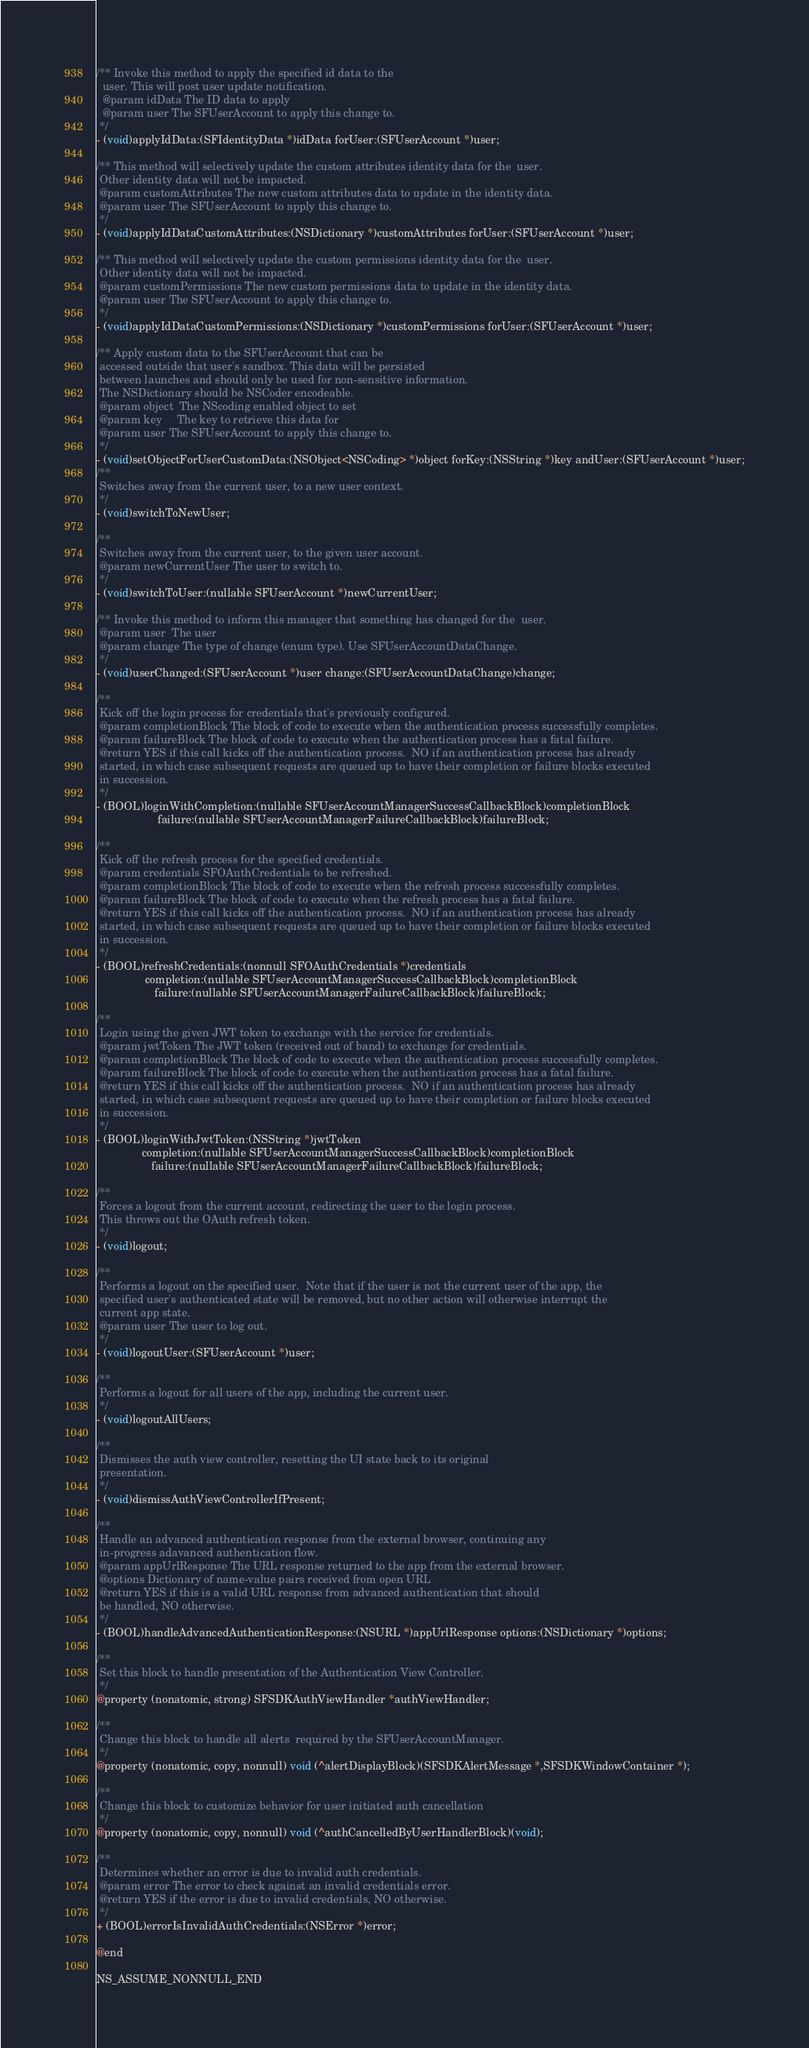<code> <loc_0><loc_0><loc_500><loc_500><_C_>/** Invoke this method to apply the specified id data to the
  user. This will post user update notification.
  @param idData The ID data to apply
  @param user The SFUserAccount to apply this change to.
 */
- (void)applyIdData:(SFIdentityData *)idData forUser:(SFUserAccount *)user;

/** This method will selectively update the custom attributes identity data for the  user.
 Other identity data will not be impacted.
 @param customAttributes The new custom attributes data to update in the identity data.
 @param user The SFUserAccount to apply this change to.
 */
- (void)applyIdDataCustomAttributes:(NSDictionary *)customAttributes forUser:(SFUserAccount *)user;

/** This method will selectively update the custom permissions identity data for the  user.
 Other identity data will not be impacted.
 @param customPermissions The new custom permissions data to update in the identity data.
 @param user The SFUserAccount to apply this change to.
 */
- (void)applyIdDataCustomPermissions:(NSDictionary *)customPermissions forUser:(SFUserAccount *)user;

/** Apply custom data to the SFUserAccount that can be
 accessed outside that user's sandbox. This data will be persisted
 between launches and should only be used for non-sensitive information.
 The NSDictionary should be NSCoder encodeable.
 @param object  The NScoding enabled object to set
 @param key     The key to retrieve this data for
 @param user The SFUserAccount to apply this change to.
 */
- (void)setObjectForUserCustomData:(NSObject<NSCoding> *)object forKey:(NSString *)key andUser:(SFUserAccount *)user;
/**
 Switches away from the current user, to a new user context.
 */
- (void)switchToNewUser;

/**
 Switches away from the current user, to the given user account.
 @param newCurrentUser The user to switch to.
 */
- (void)switchToUser:(nullable SFUserAccount *)newCurrentUser;

/** Invoke this method to inform this manager that something has changed for the  user.
 @param user  The user
 @param change The type of change (enum type). Use SFUserAccountDataChange.
 */
- (void)userChanged:(SFUserAccount *)user change:(SFUserAccountDataChange)change;

/**
 Kick off the login process for credentials that's previously configured.
 @param completionBlock The block of code to execute when the authentication process successfully completes.
 @param failureBlock The block of code to execute when the authentication process has a fatal failure.
 @return YES if this call kicks off the authentication process.  NO if an authentication process has already
 started, in which case subsequent requests are queued up to have their completion or failure blocks executed
 in succession.
 */
- (BOOL)loginWithCompletion:(nullable SFUserAccountManagerSuccessCallbackBlock)completionBlock
                    failure:(nullable SFUserAccountManagerFailureCallbackBlock)failureBlock;

/**
 Kick off the refresh process for the specified credentials.
 @param credentials SFOAuthCredentials to be refreshed.
 @param completionBlock The block of code to execute when the refresh process successfully completes.
 @param failureBlock The block of code to execute when the refresh process has a fatal failure.
 @return YES if this call kicks off the authentication process.  NO if an authentication process has already
 started, in which case subsequent requests are queued up to have their completion or failure blocks executed
 in succession.
 */
- (BOOL)refreshCredentials:(nonnull SFOAuthCredentials *)credentials
                completion:(nullable SFUserAccountManagerSuccessCallbackBlock)completionBlock
                   failure:(nullable SFUserAccountManagerFailureCallbackBlock)failureBlock;

/**
 Login using the given JWT token to exchange with the service for credentials.
 @param jwtToken The JWT token (received out of band) to exchange for credentials.
 @param completionBlock The block of code to execute when the authentication process successfully completes.
 @param failureBlock The block of code to execute when the authentication process has a fatal failure.
 @return YES if this call kicks off the authentication process.  NO if an authentication process has already
 started, in which case subsequent requests are queued up to have their completion or failure blocks executed
 in succession.
 */
- (BOOL)loginWithJwtToken:(NSString *)jwtToken
               completion:(nullable SFUserAccountManagerSuccessCallbackBlock)completionBlock
                  failure:(nullable SFUserAccountManagerFailureCallbackBlock)failureBlock;

/**
 Forces a logout from the current account, redirecting the user to the login process.
 This throws out the OAuth refresh token.
 */
- (void)logout;

/**
 Performs a logout on the specified user.  Note that if the user is not the current user of the app, the
 specified user's authenticated state will be removed, but no other action will otherwise interrupt the
 current app state.
 @param user The user to log out.
 */
- (void)logoutUser:(SFUserAccount *)user;

/**
 Performs a logout for all users of the app, including the current user.
 */
- (void)logoutAllUsers;

/**
 Dismisses the auth view controller, resetting the UI state back to its original
 presentation.
 */
- (void)dismissAuthViewControllerIfPresent;

/**
 Handle an advanced authentication response from the external browser, continuing any
 in-progress adavanced authentication flow.
 @param appUrlResponse The URL response returned to the app from the external browser.
 @options Dictionary of name-value pairs received from open URL
 @return YES if this is a valid URL response from advanced authentication that should
 be handled, NO otherwise.
 */
- (BOOL)handleAdvancedAuthenticationResponse:(NSURL *)appUrlResponse options:(NSDictionary *)options;

/**
 Set this block to handle presentation of the Authentication View Controller.
 */
@property (nonatomic, strong) SFSDKAuthViewHandler *authViewHandler;

/**
 Change this block to handle all alerts  required by the SFUserAccountManager.
 */
@property (nonatomic, copy, nonnull) void (^alertDisplayBlock)(SFSDKAlertMessage *,SFSDKWindowContainer *);

/**
 Change this block to customize behavior for user initiated auth cancellation
 */
@property (nonatomic, copy, nonnull) void (^authCancelledByUserHandlerBlock)(void);

/**
 Determines whether an error is due to invalid auth credentials.
 @param error The error to check against an invalid credentials error.
 @return YES if the error is due to invalid credentials, NO otherwise.
 */
+ (BOOL)errorIsInvalidAuthCredentials:(NSError *)error;

@end

NS_ASSUME_NONNULL_END
</code> 